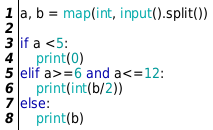<code> <loc_0><loc_0><loc_500><loc_500><_Python_>a, b = map(int, input().split())

if a <5:
    print(0)
elif a>=6 and a<=12:
    print(int(b/2))
else:
    print(b)</code> 